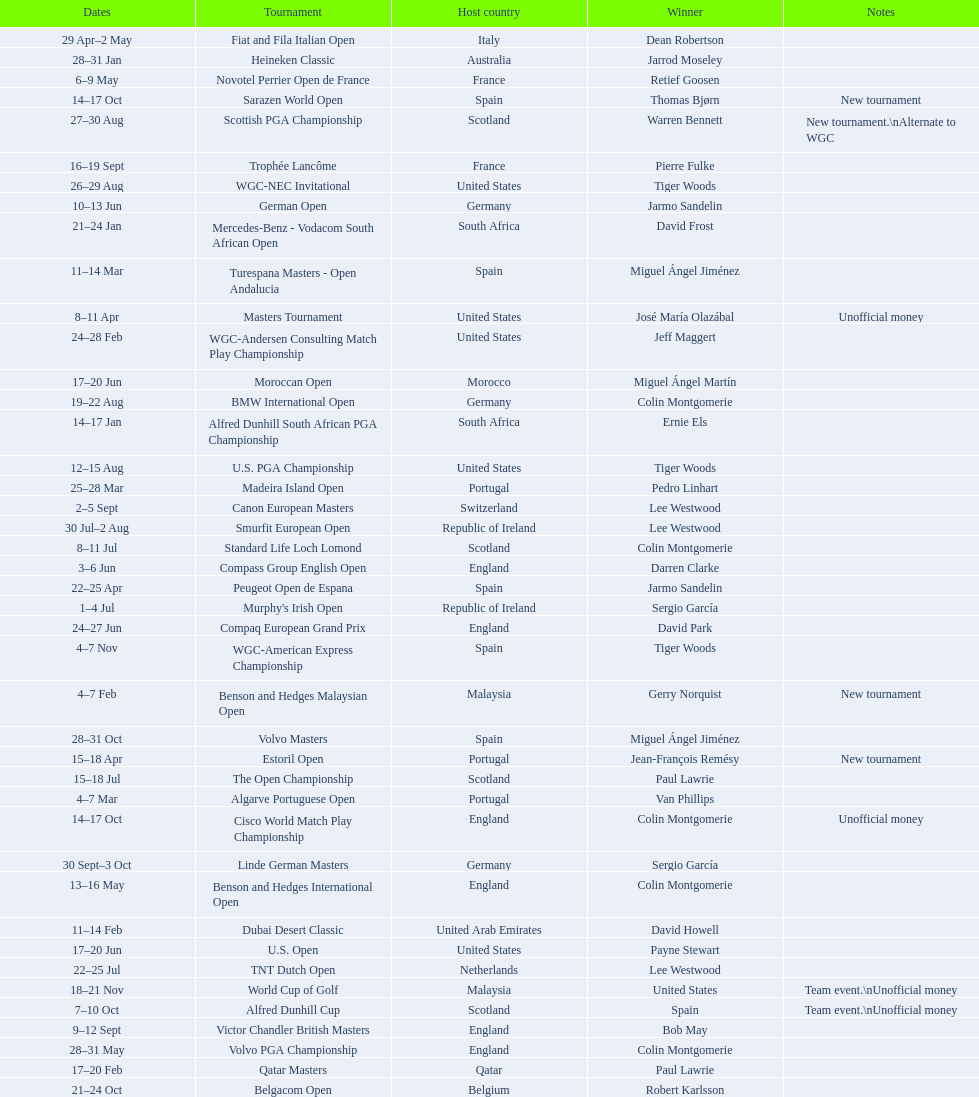How long did the estoril open last? 3 days. 